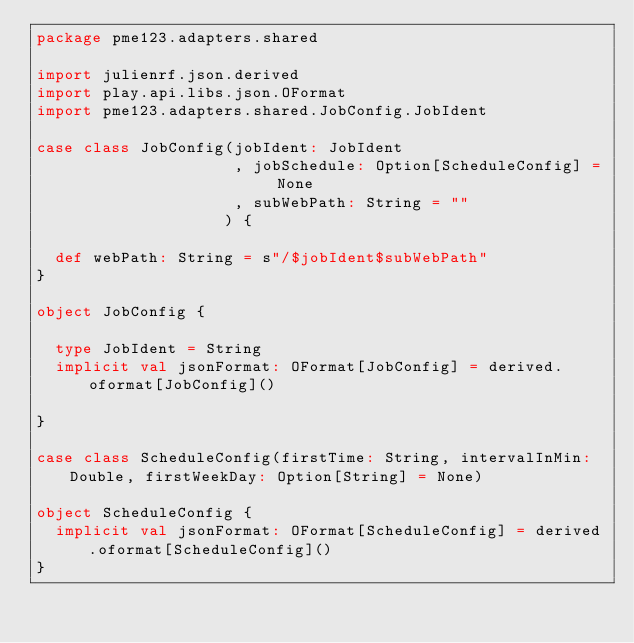<code> <loc_0><loc_0><loc_500><loc_500><_Scala_>package pme123.adapters.shared

import julienrf.json.derived
import play.api.libs.json.OFormat
import pme123.adapters.shared.JobConfig.JobIdent

case class JobConfig(jobIdent: JobIdent
                     , jobSchedule: Option[ScheduleConfig] = None
                     , subWebPath: String = ""
                    ) {

  def webPath: String = s"/$jobIdent$subWebPath"
}

object JobConfig {

  type JobIdent = String
  implicit val jsonFormat: OFormat[JobConfig] = derived.oformat[JobConfig]()

}

case class ScheduleConfig(firstTime: String, intervalInMin: Double, firstWeekDay: Option[String] = None)

object ScheduleConfig {
  implicit val jsonFormat: OFormat[ScheduleConfig] = derived.oformat[ScheduleConfig]()
}</code> 